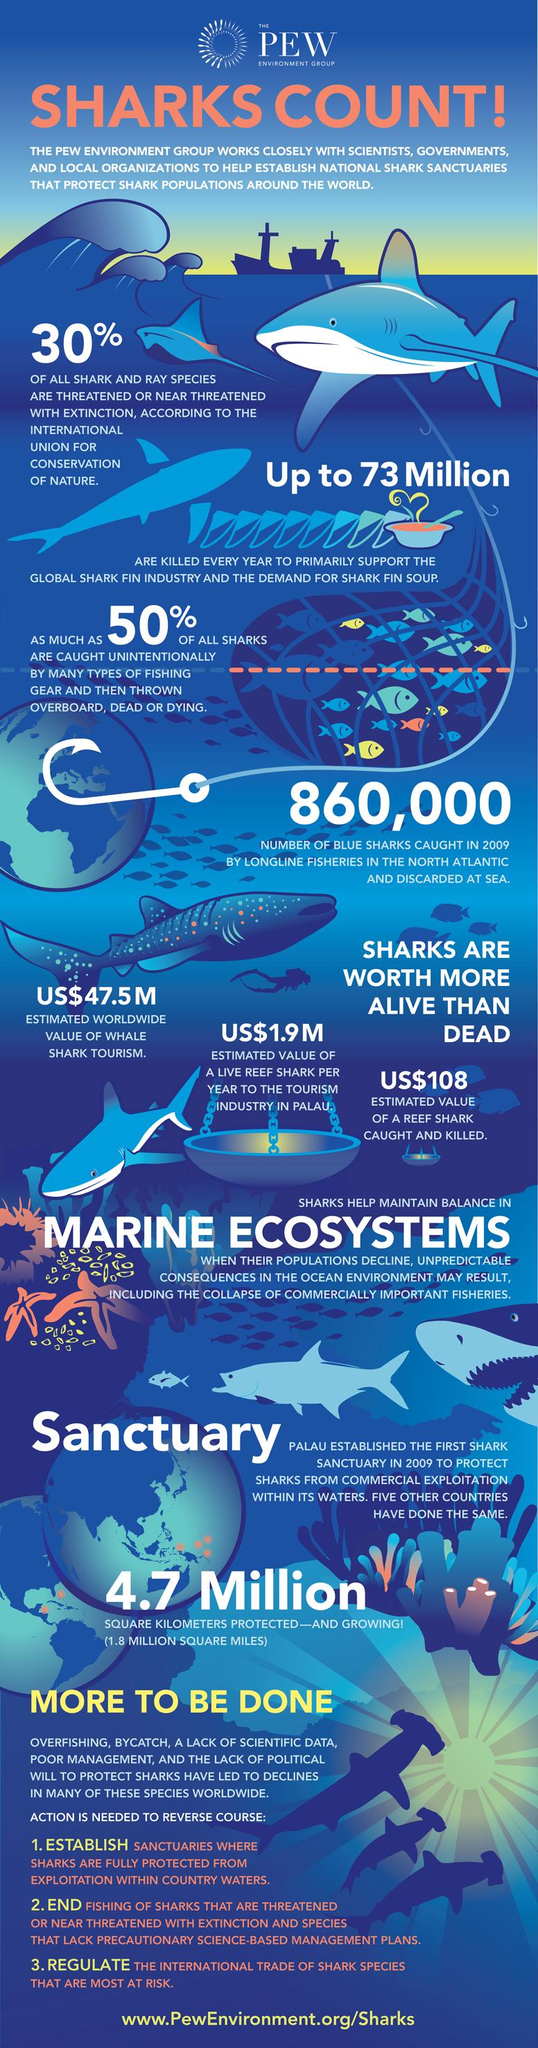Point out several critical features in this image. The estimated value of a reef shark caught and killed is US$108. An estimated worldwide value of whale shark tourism is US$47.5 million. 